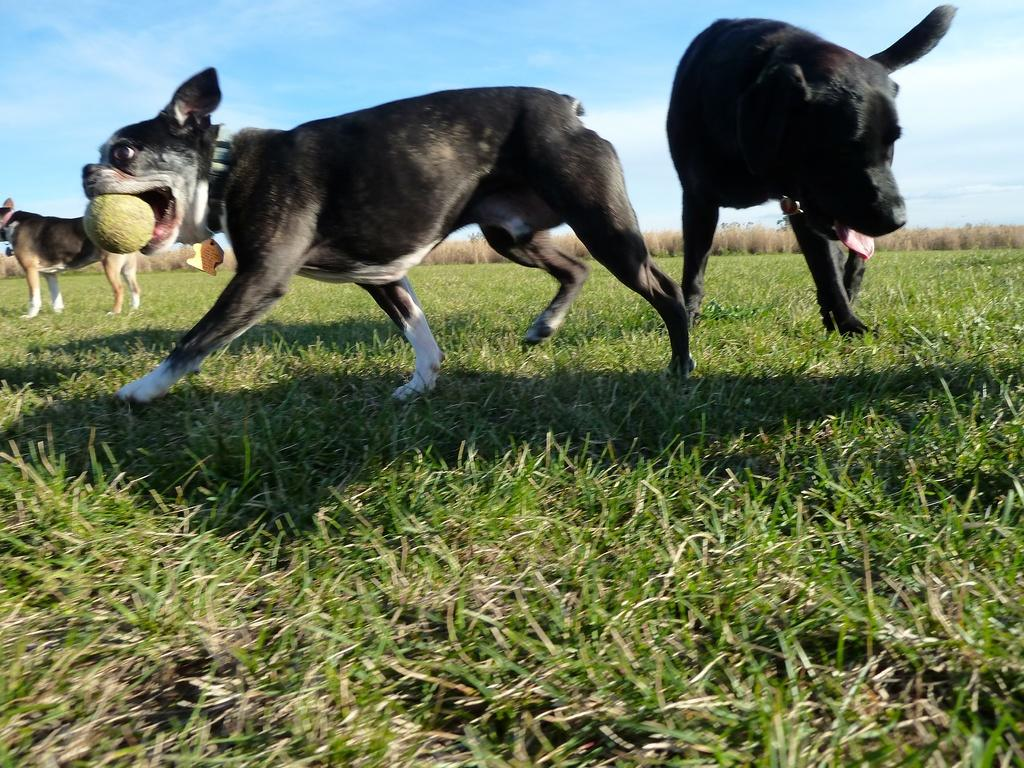What animals can be seen in the image? There are dogs in the image. Where are the dogs located? The dogs are on a grassland. What is one dog doing with an object in its mouth? One dog is holding a ball in its mouth. What is the action of the dog with the ball? The dog with the ball is walking on the grassland. What is visible at the top of the image? The sky is visible at the top of the image. Can you see a stream of copper flowing through the cemetery in the image? There is no stream of copper or cemetery present in the image; it features dogs on a grassland. 